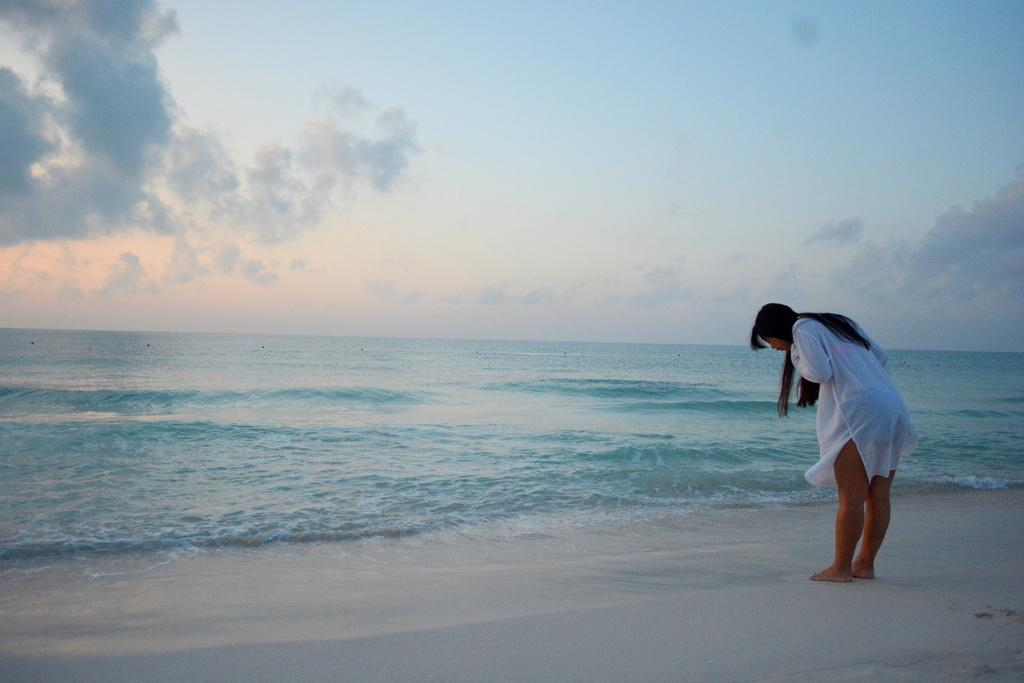What is the person in the image standing on? The person is standing on the sand. What is located behind the person in the image? The person is in front of the sea. What can be seen in the background of the image? The sky is visible in the background of the image. What type of note is the person holding in their wrist in the image? There is no note or wrist visible in the image; the person is simply standing on the sand in front of the sea. 